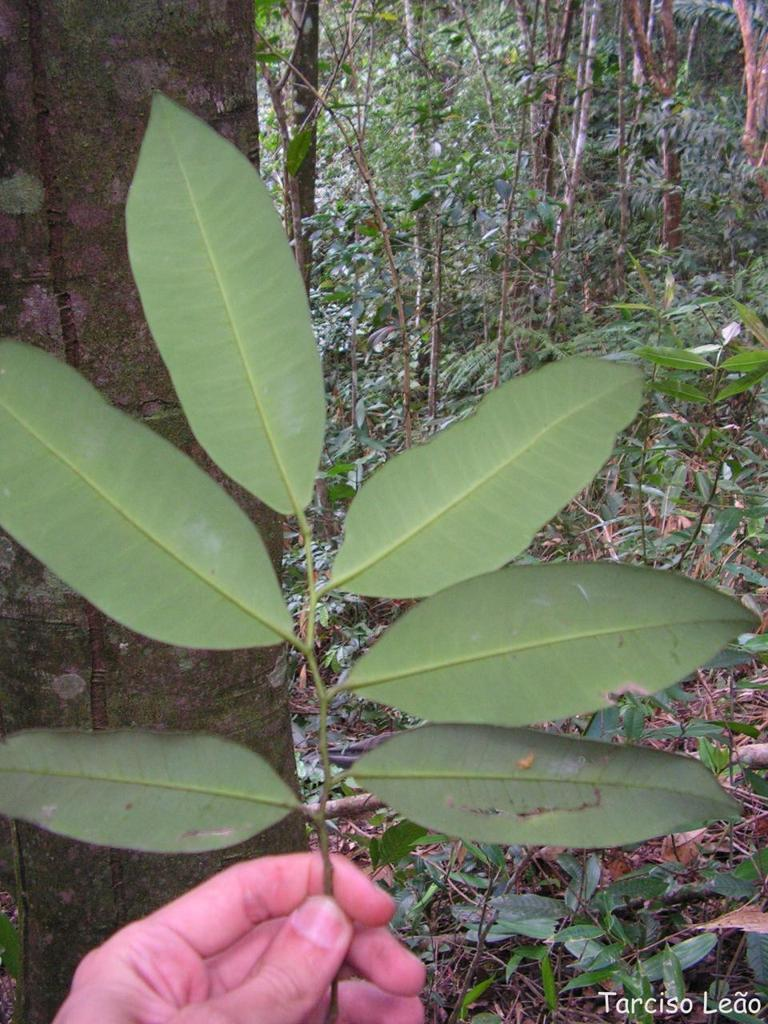What is the main subject in the image? There is a human in the image. What is the human doing in the image? The human is holding leaves in the image. What can be seen in the background of the image? There are trees in the image. What organization is the human affiliated with in the image? There is no information about any organization in the image, as it only shows a human holding leaves with trees in the background. 